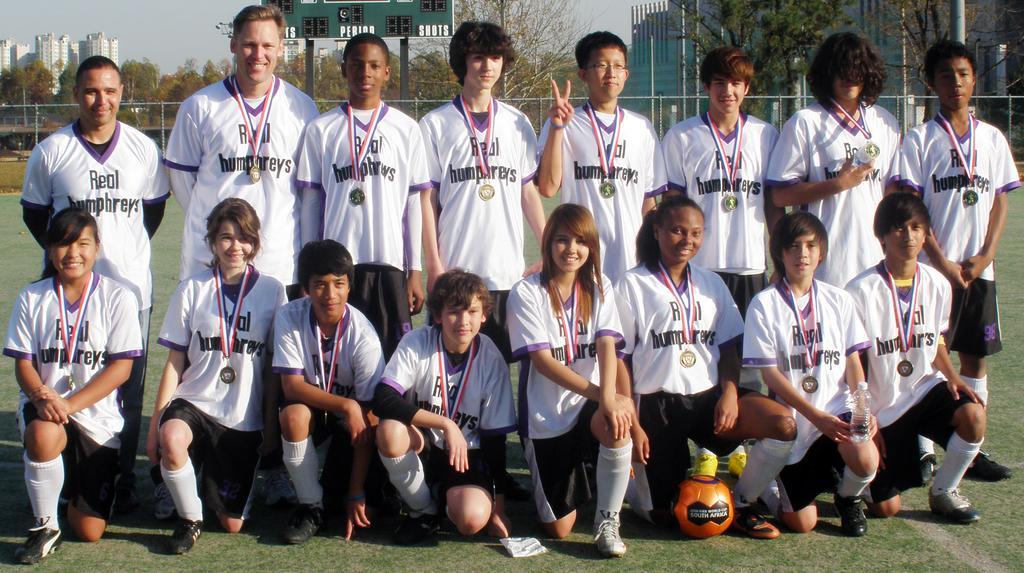Could you give a brief overview of what you see in this image? In this image there are group of football players posing for the group pic. All the players are having a gold medal. In the background there is a scorecard. On the left side top corner there are buildings in the background. Below the scoreboard there is a fencing. 